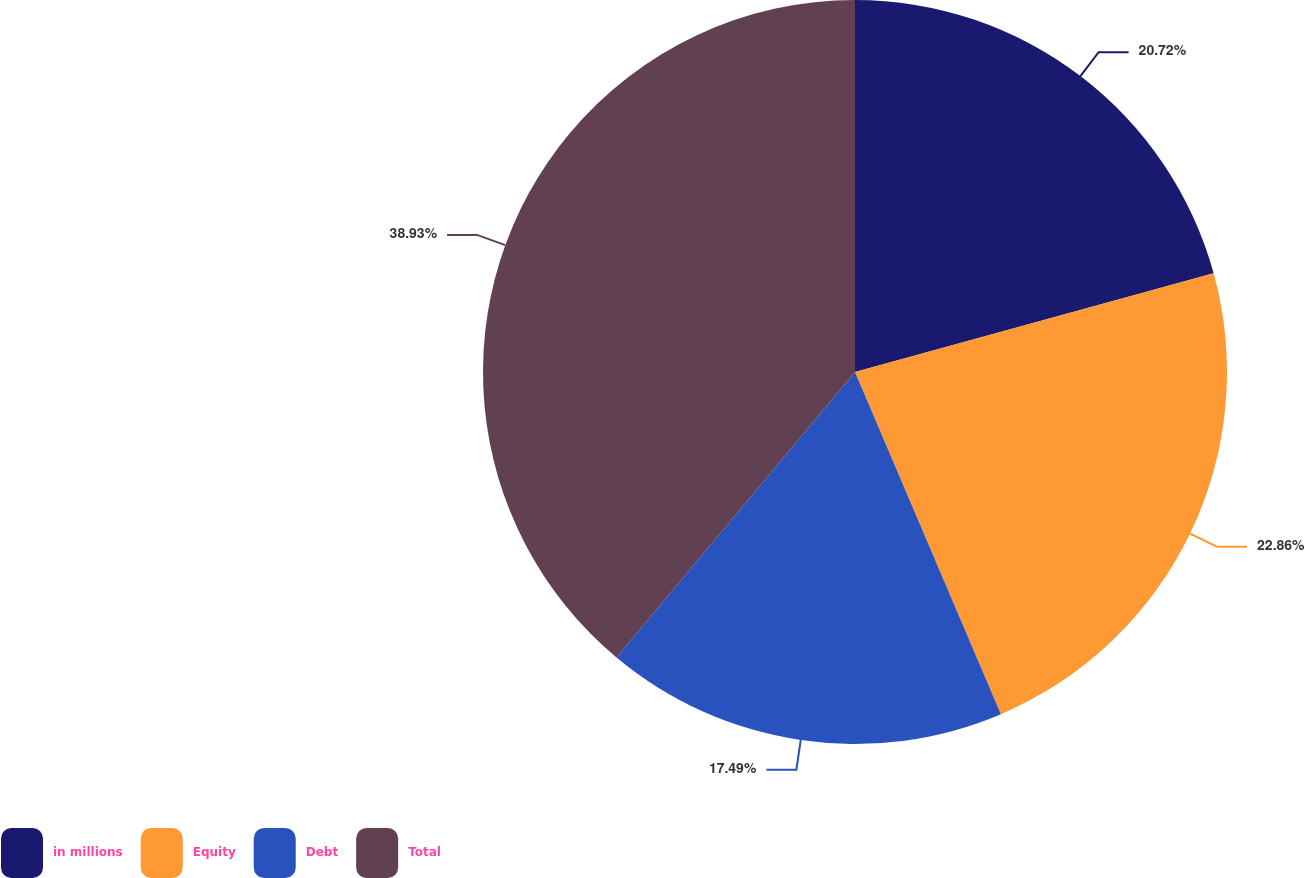Convert chart. <chart><loc_0><loc_0><loc_500><loc_500><pie_chart><fcel>in millions<fcel>Equity<fcel>Debt<fcel>Total<nl><fcel>20.72%<fcel>22.86%<fcel>17.49%<fcel>38.92%<nl></chart> 